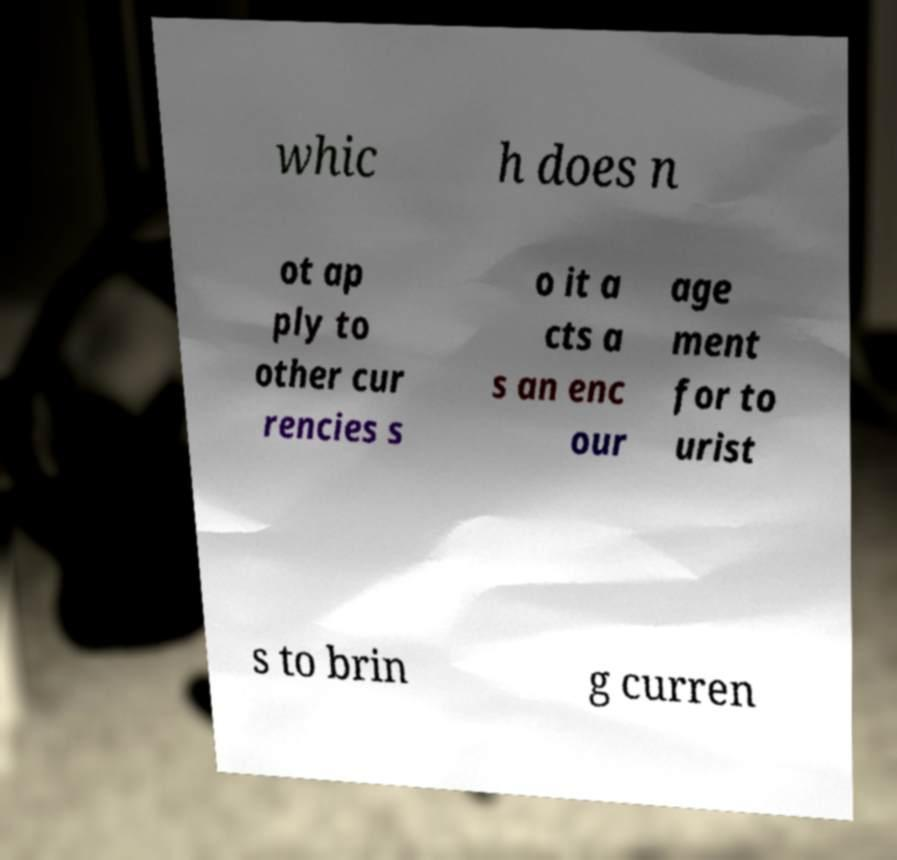For documentation purposes, I need the text within this image transcribed. Could you provide that? whic h does n ot ap ply to other cur rencies s o it a cts a s an enc our age ment for to urist s to brin g curren 